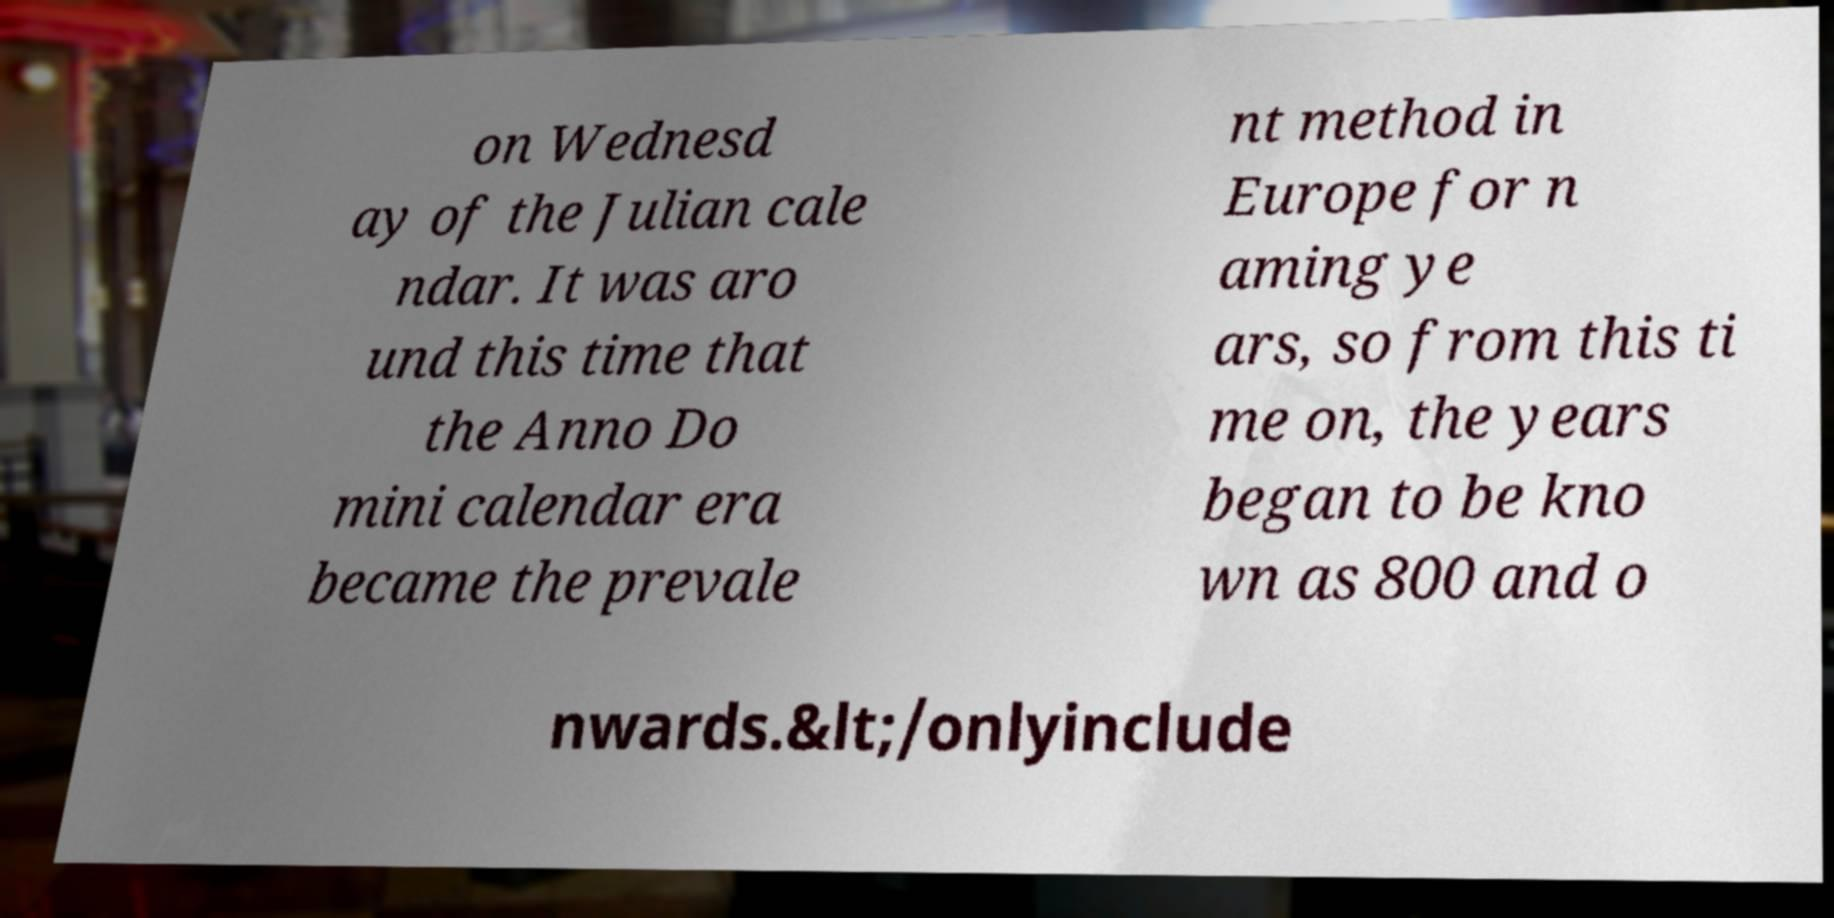What messages or text are displayed in this image? I need them in a readable, typed format. on Wednesd ay of the Julian cale ndar. It was aro und this time that the Anno Do mini calendar era became the prevale nt method in Europe for n aming ye ars, so from this ti me on, the years began to be kno wn as 800 and o nwards.&lt;/onlyinclude 